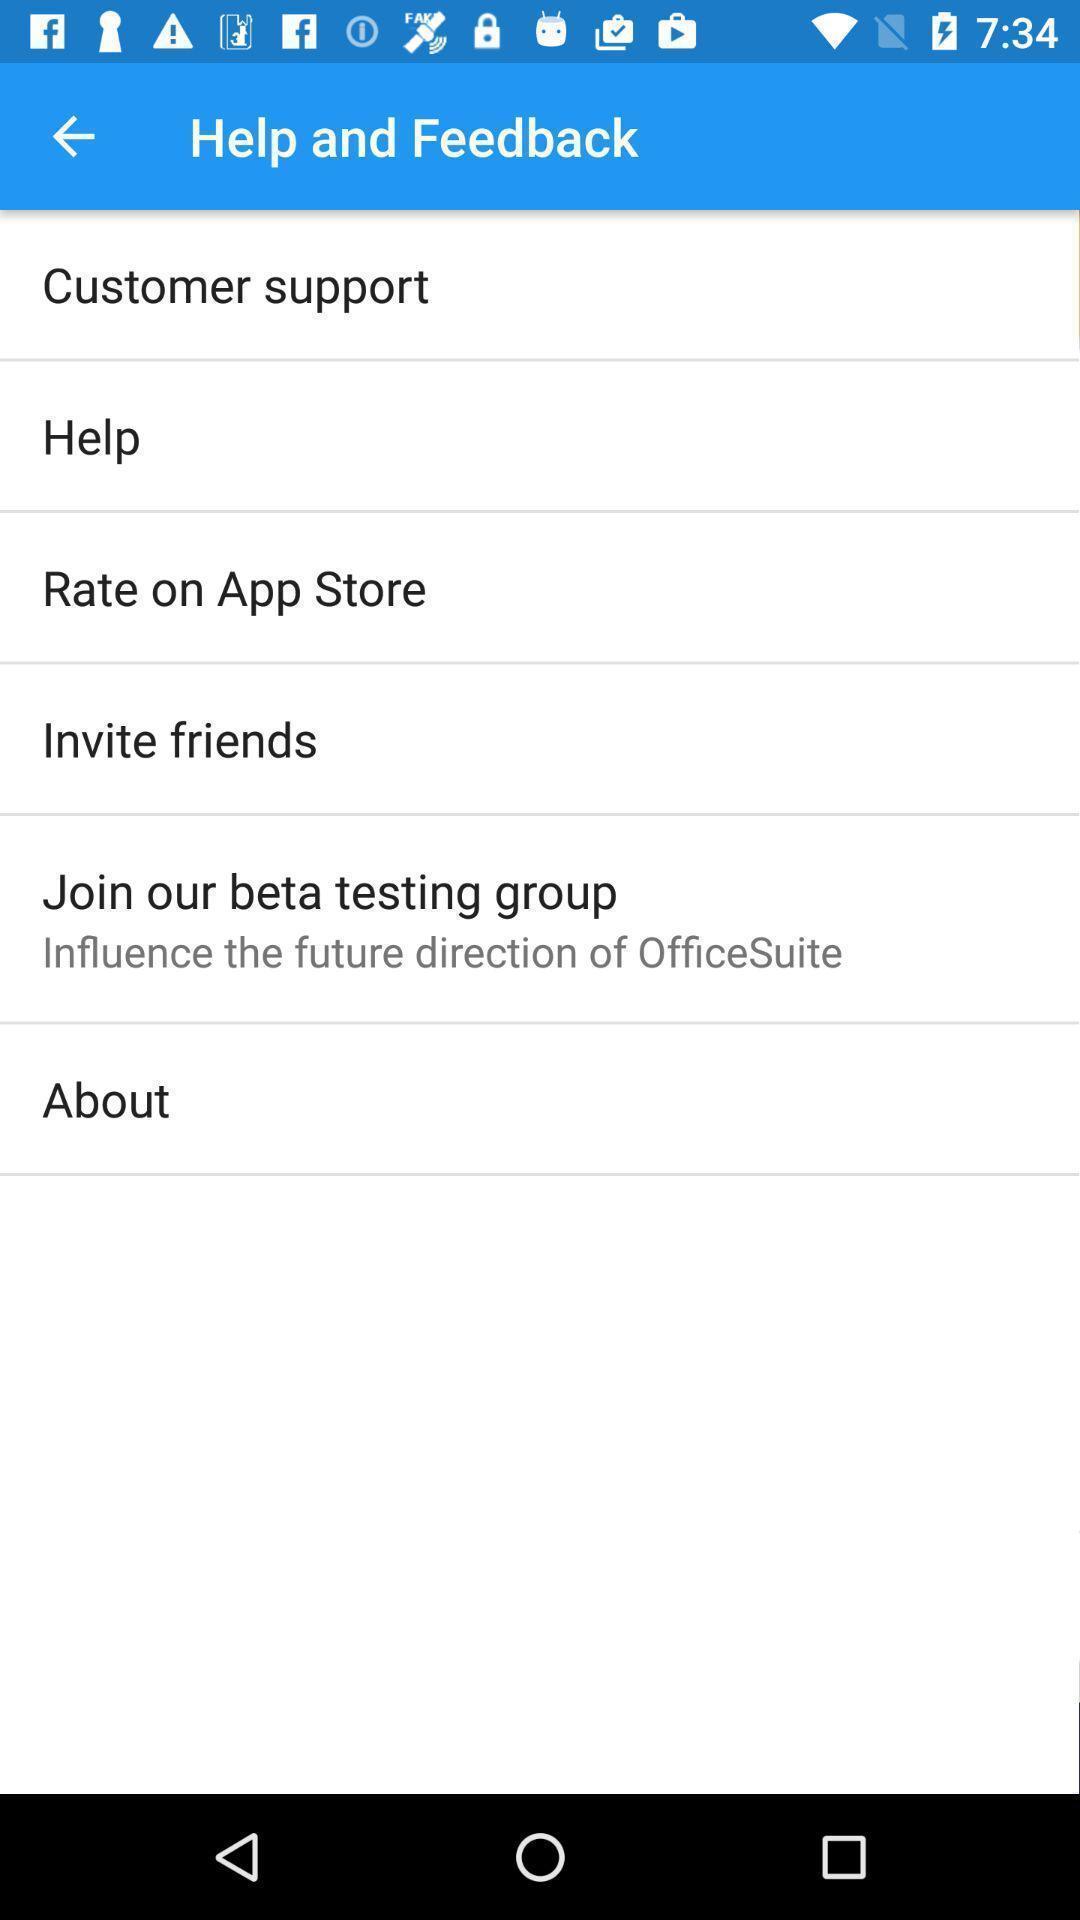Provide a description of this screenshot. Page showing different options in help and feedback. 